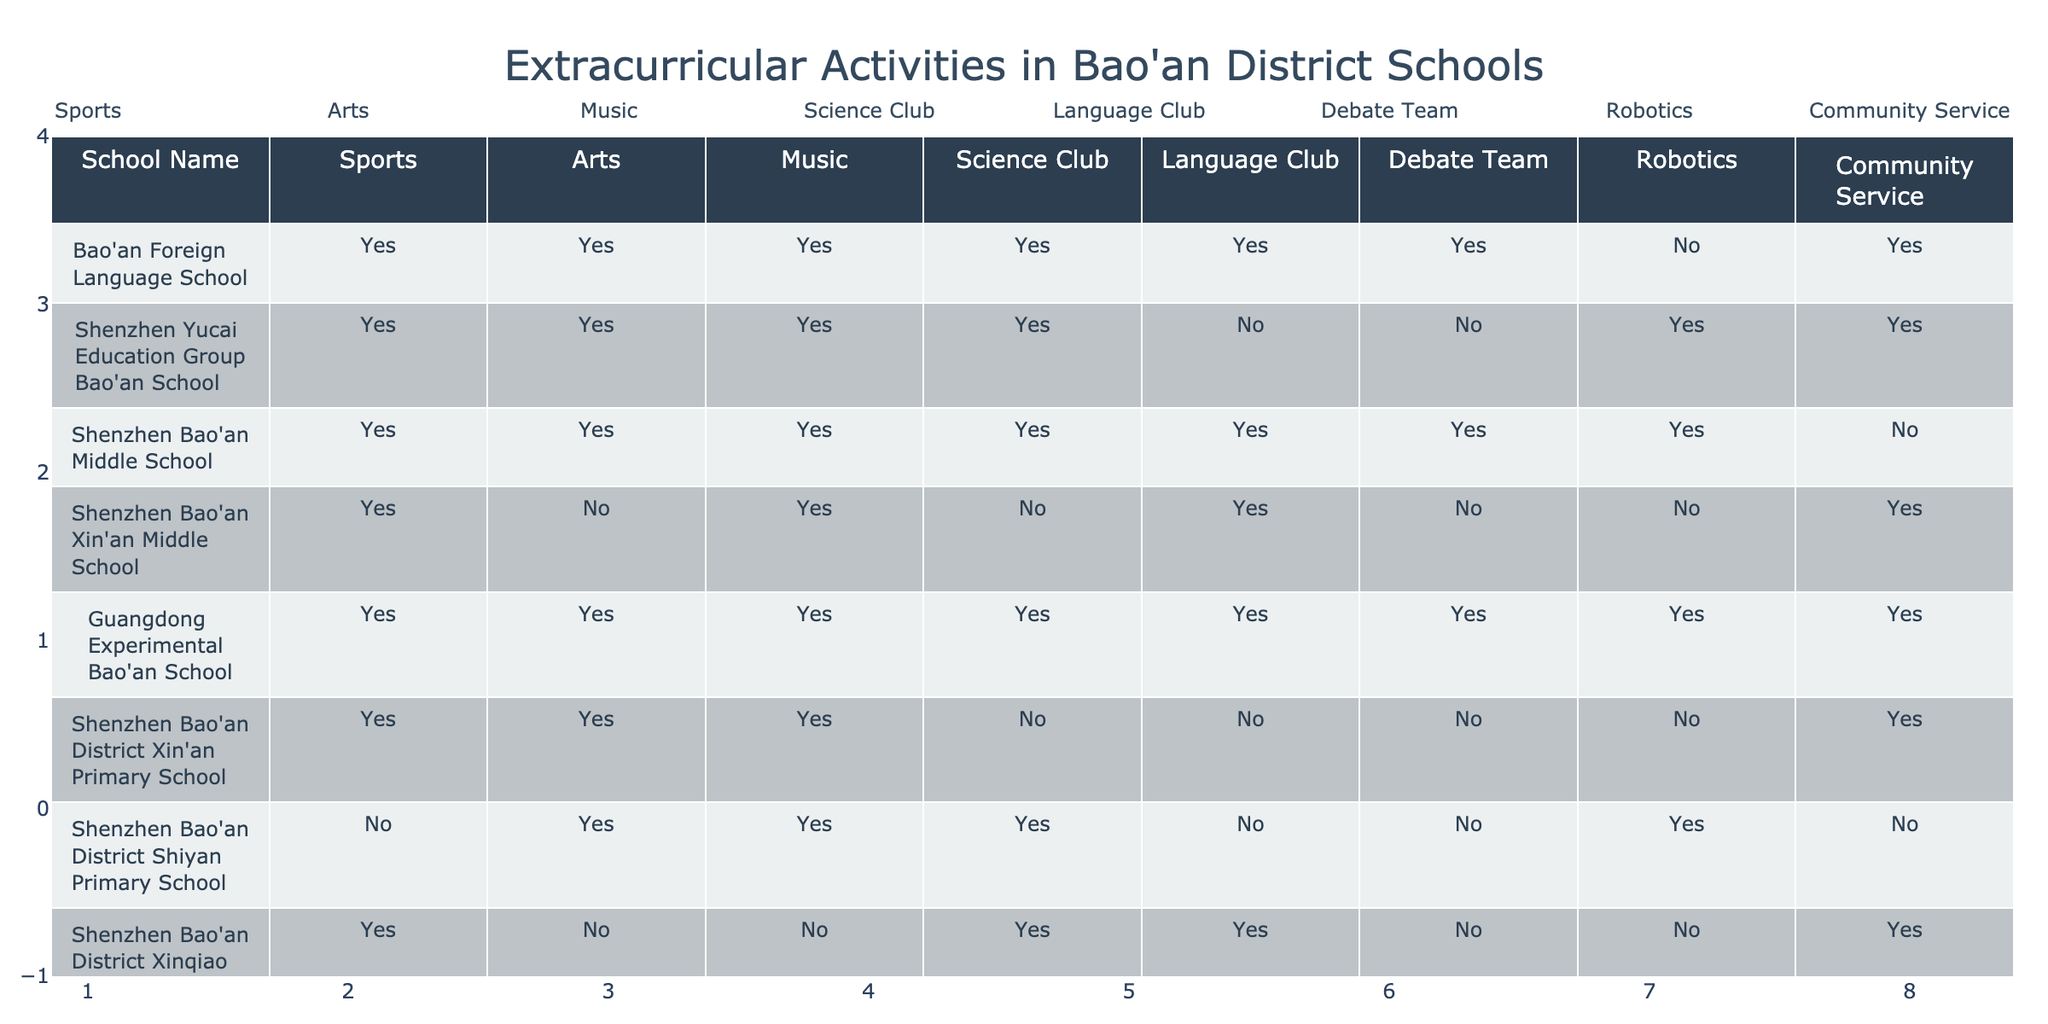What schools offer a Science Club? By looking at the table, I can see the schools that have "Yes" listed under the Science Club column. These schools are Bao'an Foreign Language School, Shenzhen Yucai Education Group Bao'an School, Shenzhen Bao'an Middle School, Guangdong Experimental Bao'an School, Shenzhen Bao'an District Xin'an Primary School, Shenzhen Bao'an District Shiyan Primary School, and Shenzhen Bao'an District Xinqiao Primary School.
Answer: Bao'an Foreign Language School, Shenzhen Yucai Education Group Bao'an School, Shenzhen Bao'an Middle School, Guangdong Experimental Bao'an School, Shenzhen Bao'an District Xin'an Primary School, Shenzhen Bao'an District Shiyan Primary School, Shenzhen Bao'an District Xinqiao Primary School Does Shenzhen Bao'an Xin'an Middle School have a Robotics program? The Robotics column indicates whether each school offers a Robotics program or not. Shenzhen Bao'an Xin'an Middle School has "No" under the Robotics column.
Answer: No How many schools provide Community Service activities? To find the number of schools that provide Community Service, I look at the Community Service column and count the number of "Yes" values. The schools that offer Community Service are Bao'an Foreign Language School, Shenzhen Yucai Education Group Bao'an School, Guangdong Experimental Bao'an School, Shenzhen Bao'an District Xin'an Primary School, Shenzhen Bao'an District Songgang Primary School. This gives us a total of 5 schools.
Answer: 5 Which school has the most extracurricular activities available? I need to count the total number of "Yes" answers for each school across all categories. After counting, I find that Guangdong Experimental Bao'an School has "Yes" for all eight categories, resulting in 8 extracurricular activities.
Answer: Guangdong Experimental Bao'an School Is it true that Guangdong Experimental Bao'an School offers all types of extracurricular activities? This requires checking if Guangdong Experimental Bao'an School has "Yes" for every single extracurricular activity listed in the table. Reviewing the table confirms that it does indeed have "Yes" for Sports, Arts, Music, Science Club, Language Club, Debate Team, Robotics, and Community Service.
Answer: Yes How many schools have no Debate Team? I look at the Debate Team column and count the number of "No" values. The schools that do not have a Debate Team are Shenzhen Bao'an District Xin'an Middle School, Shenzhen Bao'an District Shiyan Primary School, and Shenzhen Bao'an District Xinqiao Primary School, totaling 3 schools.
Answer: 3 Which extracurricular activity is offered by Shenzhen Bao'an Bilingual School? Shenzhen Bao'an Bilingual School has "Yes" for all categories, meaning it offers Sports, Arts, Music, Science Club, Language Club, Debate Team, Robotics, and Community Service.
Answer: All extracurricular activities How many extracurricular activities does Shenzhen Bao'an Middle School offer compared to Shenzhen Bao'an District Shiyan Primary School? For Shenzhen Bao'an Middle School, all activities are "Yes," giving a total of 8. For Shenzhen Bao'an District Shiyan Primary School, it offers Sports, Arts, Music, and Community Service ("Yes" for 4 activities). Thus, Shenzhen Bao'an Middle School offers 4 more activities than Shenzhen Bao'an District Shiyan Primary School.
Answer: Shenzhen Bao'an Middle School offers 4 more activities 